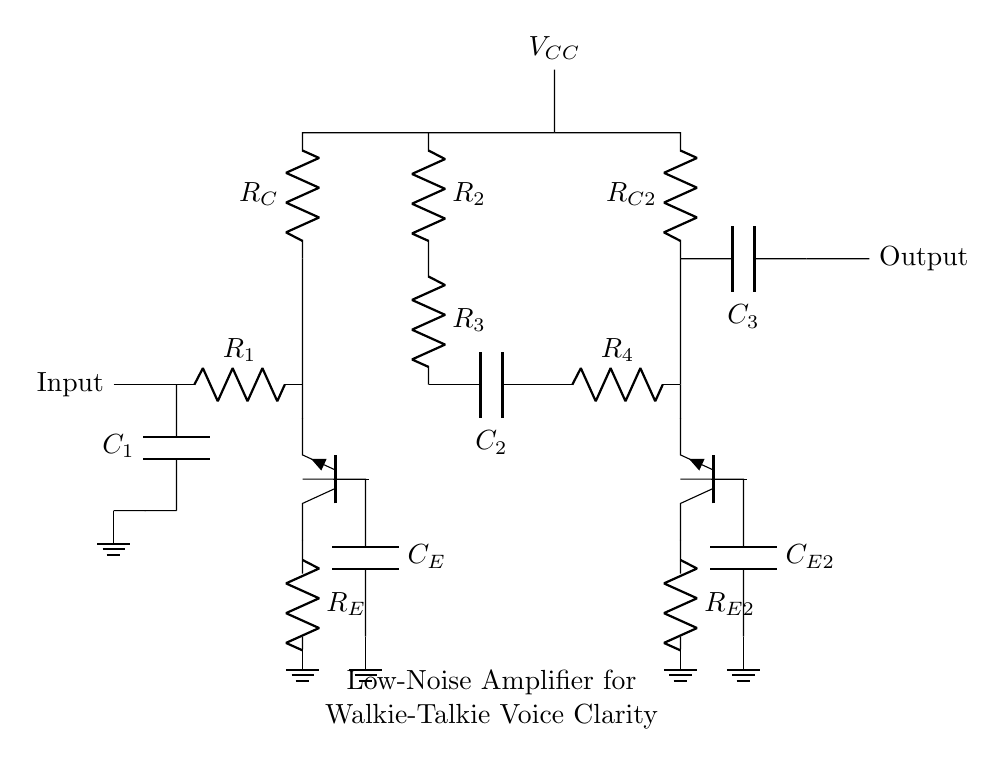What is the type of transistors used in this amplifier? The transistors shown in the circuit are labeled as Tnpn, indicating they are NPN bipolar junction transistors. This is derived from the labels on the diagram.
Answer: NPN What does the capacitor C1 do in this circuit? Capacitor C1 is connected at the input; it typically blocks DC voltage while allowing AC signals (like audio) to pass. This is based on the function of capacitors in amplifier circuits to filter frequencies.
Answer: Blocks DC How many stages are present in this amplifier circuit? The circuit demonstrates two transistor stages, each with its own biasing and output setup, which is seen from the two NPN components in series.
Answer: Two What is the purpose of the resistor R_E? Resistor R_E is used as an emitter resistor, which provides stability by improving the biasing of the transistor and reducing distortion. This can be inferred from its placement in the emitter leg of the transistor circuit.
Answer: Stability What is the role of capacitors C2 and C3 in this circuit? Capacitors C2 and C3 are coupling capacitors that connect the stages while preventing DC voltage from affecting the next stage. Their positions show this function, which is standard in amplifier design.
Answer: Coupling What is the function of the bias network formed by R2 and R3? The bias network composed of R2 and R3 sets the operating point of the transistor Q1, ensuring it stays in the correct region for amplification. This is understood through their setup affecting voltage at the base of the transistor.
Answer: Sets operating point 